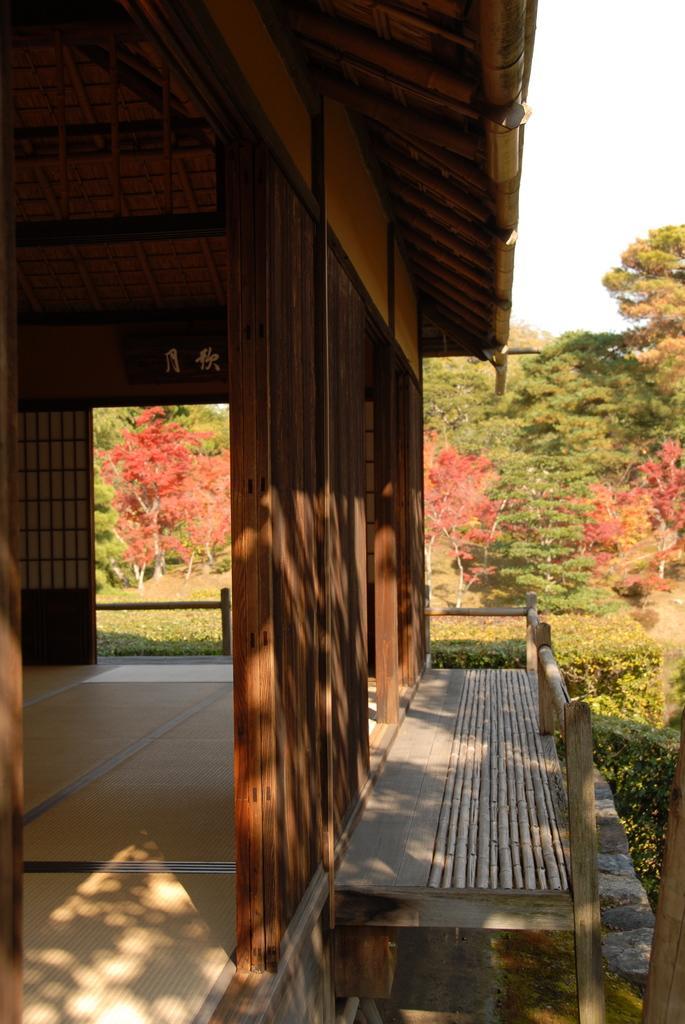In one or two sentences, can you explain what this image depicts? In the foreground of the picture there is a house build with wood. In the center of the picture there are plants, flowers and trees. 